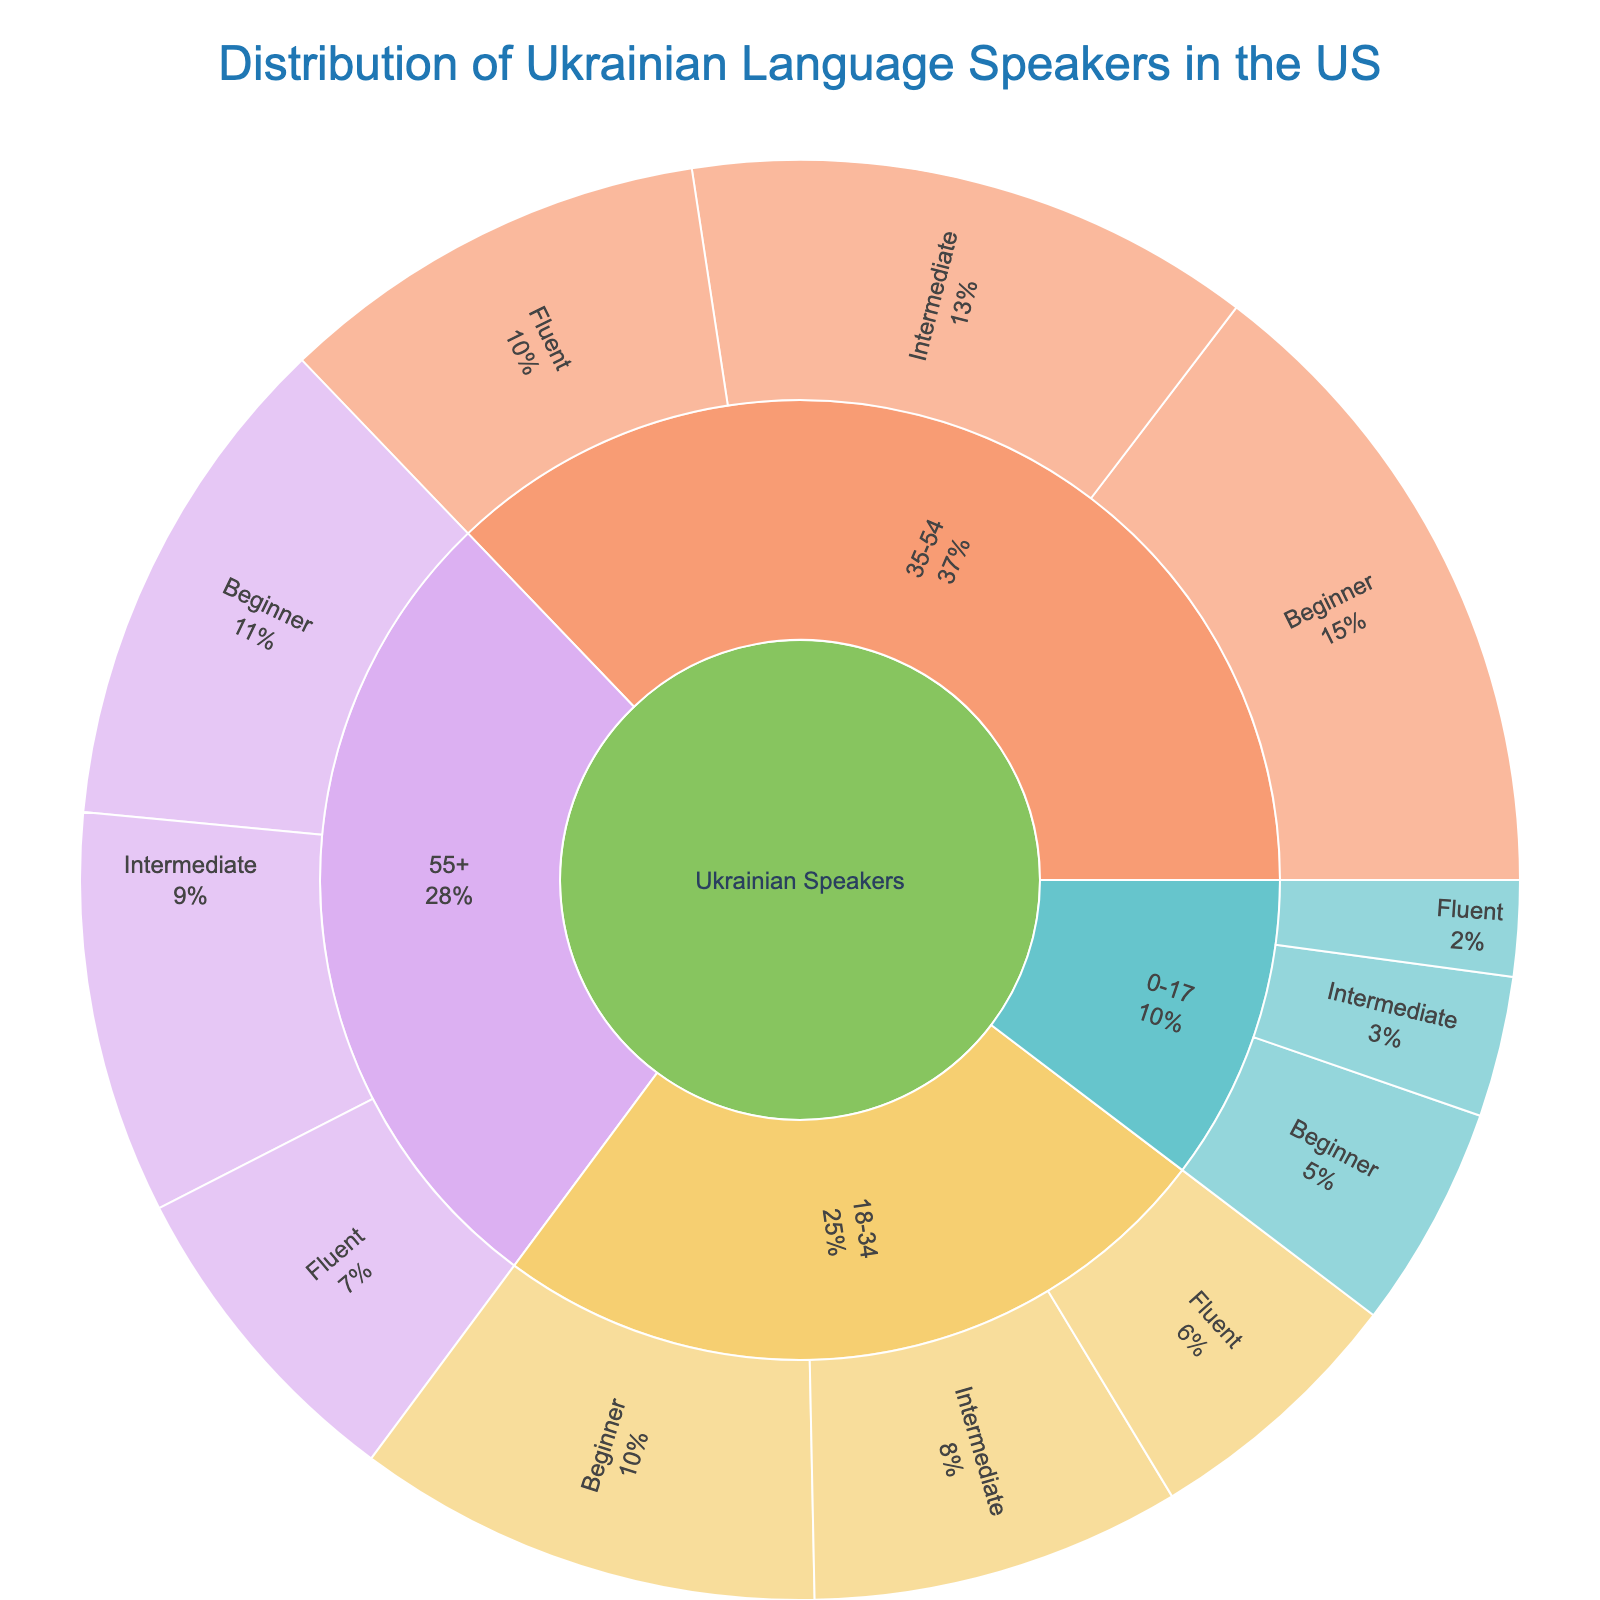what is the title of the Sunburst Plot? The title is usually at the top center of the plot. By looking at that area, you can see the title, which should be easily readable.
Answer: Distribution of Ukrainian Language Speakers in the US Which age group has the highest number of Beginner proficiency speakers? Look at the sections divided by age groups and identify the one with the largest segment for Beginner proficiency speakers.
Answer: 35-54 What's the total number of Ukrainian speakers aged 55+? Sum up the numbers for all proficiency levels within the 55+ age group: 51000 (Fluent) + 63000 (Intermediate) + 79000 (Beginner).
Answer: 193000 How many Fluent Ukrainian speakers are there in the age group 18-34? Look at the Fluent segment under the 18-34 age group to find the corresponding value.
Answer: 42000 Which proficiency level is least common among the 0-17 age group? Compare the sizes of the segments under the 0-17 age group for each proficiency level: Fluent, Intermediate, Beginner, and identify the smallest one.
Answer: Fluent Which age group has the highest total number of Ukrainian speakers? Sum up the values for all proficiency levels within each age group and compare them to find the highest: (0-17, 18-34, 35-54, 55+).
Answer: 35-54 How does the number of Intermediate speakers in the 35-54 age group compare to the number of Intermediate speakers in the 18-34 age group? Look at the Intermediate segments for both age groups and check the values: 89000 (35-54) and 58000 (18-34).
Answer: 35-54 has more Intermediate speakers What is the percentage of Fluent speakers among the total Ukrainian speakers aged 35-54? Divide the number of Fluent speakers in the 35-54 age group by the total number of Ukrainian speakers in that age group and convert to a percentage: 68000 / (68000 + 89000 + 102000).
Answer: Approximately 25.4% Which age group accounts for the smallest percentage of the total Ukrainian-speaking population? Sum up the total population for each age group and find the one with the smallest sum: (0-17, 18-34, 35-54, 55+).
Answer: 0-17 Which proficiency level is most common among all Ukrainian speakers in the US? Sum up the population for each proficiency level across all age groups and find the highest: Fluent, Intermediate, Beginner.
Answer: Beginner 